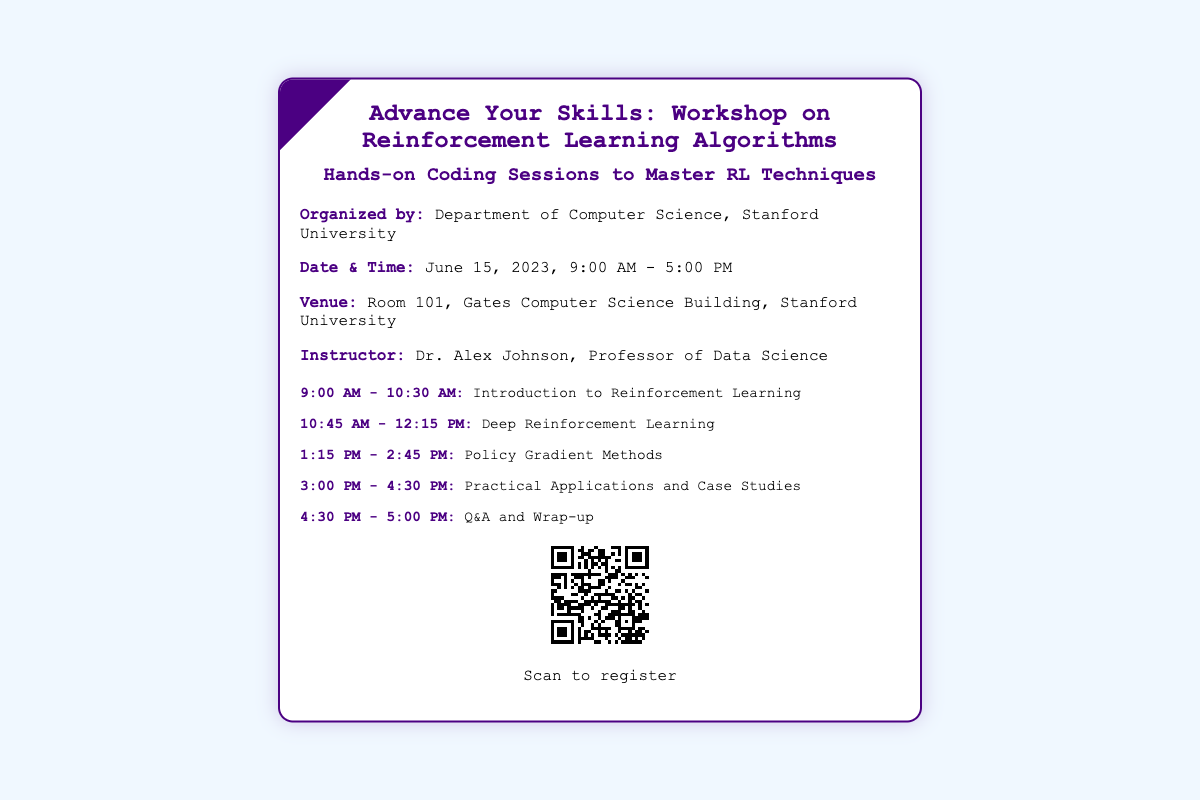what is the title of the workshop? The title is found at the top of the ticket.
Answer: Advance Your Skills: Workshop on Reinforcement Learning Algorithms who is the instructor for the workshop? The instructor is mentioned in the information section of the ticket.
Answer: Dr. Alex Johnson what is the date of the workshop? The date is clearly stated in the information section of the ticket.
Answer: June 15, 2023 how long is the workshop scheduled to last? The duration is inferred from the starting and ending times provided in the date and time section.
Answer: 8 hours what time does the workshop start? The start time is included in the date and time details.
Answer: 9:00 AM which room is the workshop taking place in? The venue information specifies the room for the event.
Answer: Room 101 how many coding sessions are scheduled in the workshop? The schedule lists distinct sessions throughout the day.
Answer: 4 what is the last activity of the workshop? The last activity is specified in the schedule section of the ticket.
Answer: Q&A and Wrap-up where is the venue located? The location is provided in the venue details.
Answer: Gates Computer Science Building, Stanford University 